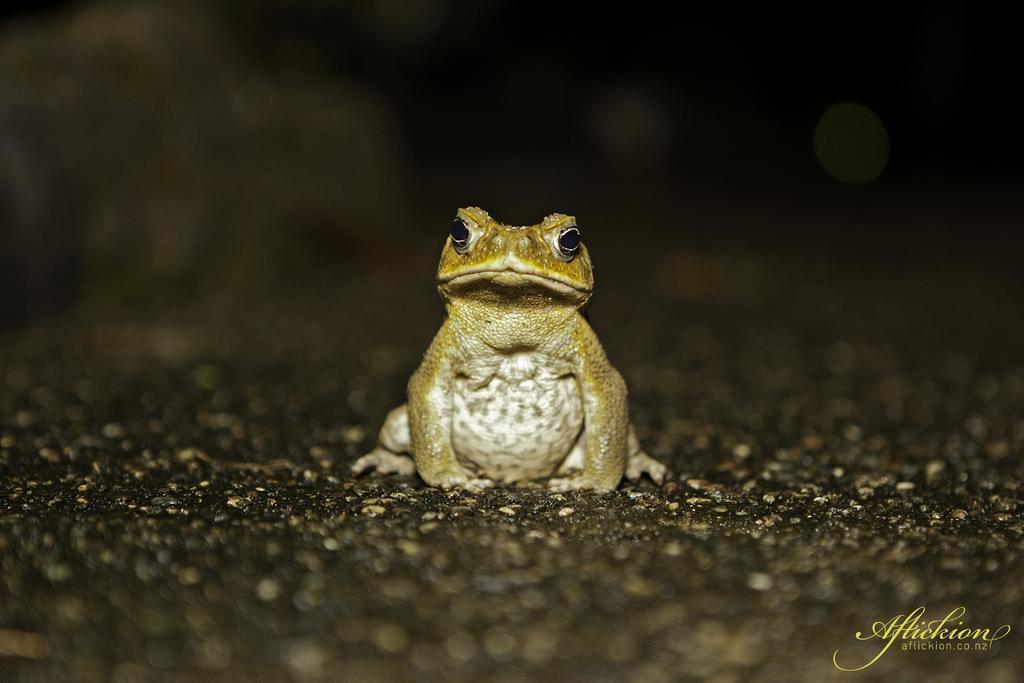In one or two sentences, can you explain what this image depicts? In the image there is a frog on the ground. In the bottom right corner of the image there is a name. 